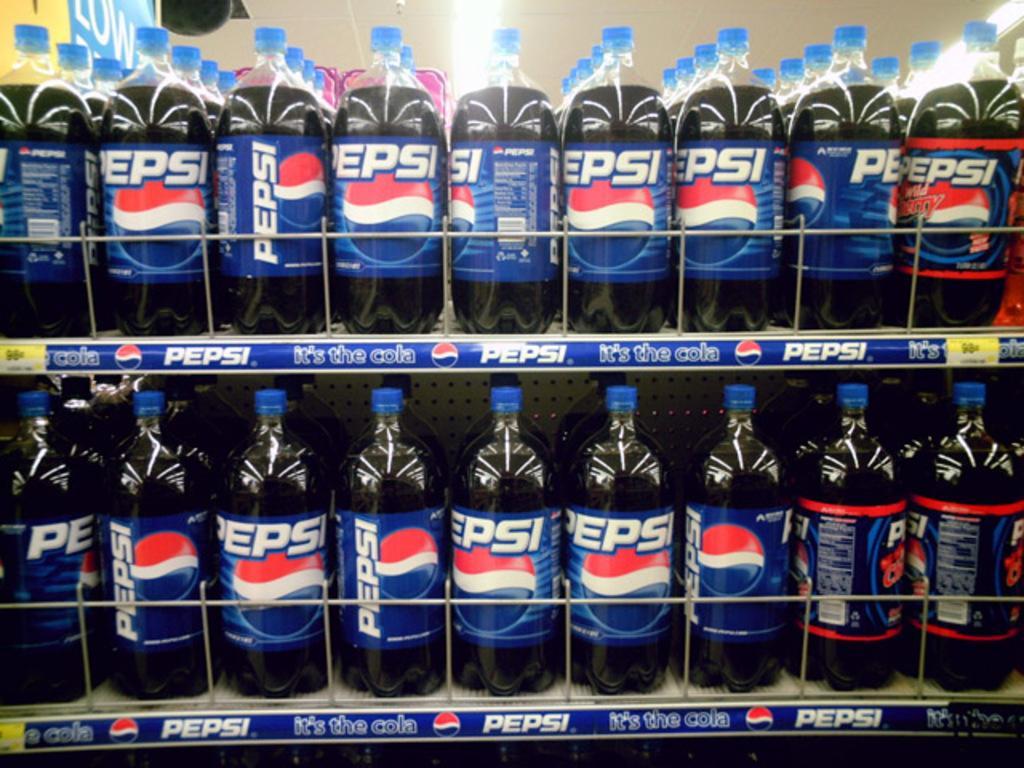How would you summarize this image in a sentence or two? In the image we can see there are pepsi juice bottles in the shelf. 